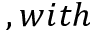Convert formula to latex. <formula><loc_0><loc_0><loc_500><loc_500>, w i t h</formula> 